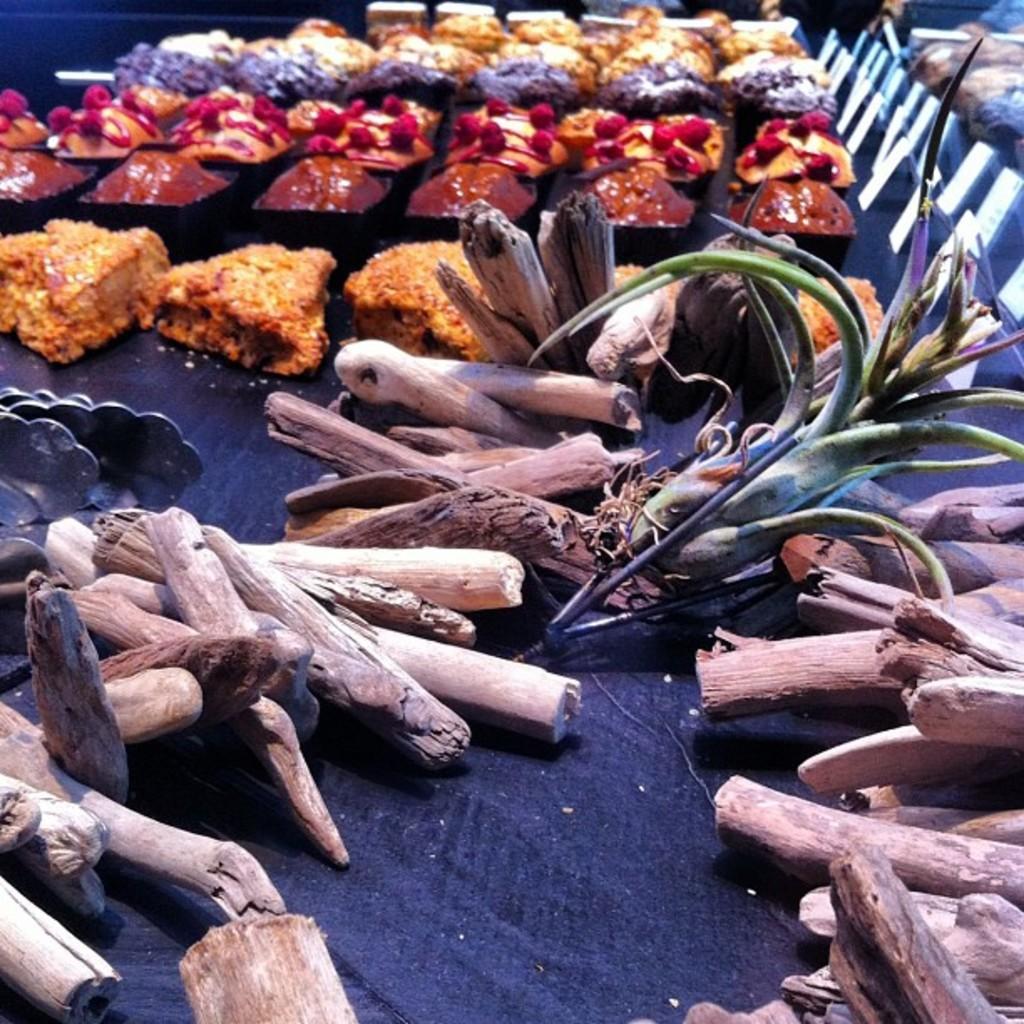Please provide a concise description of this image. In this image we can see food items, wood placed on the table. 